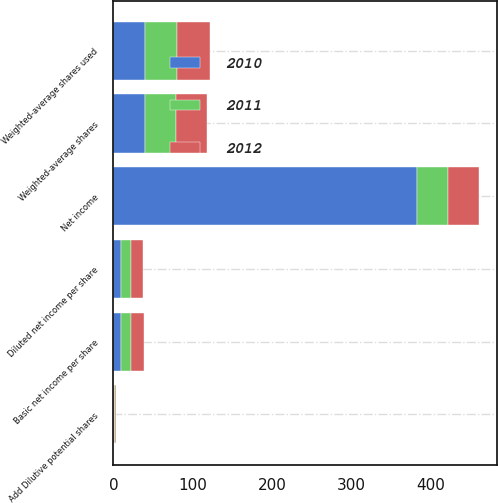Convert chart. <chart><loc_0><loc_0><loc_500><loc_500><stacked_bar_chart><ecel><fcel>Net income<fcel>Weighted-average shares<fcel>Basic net income per share<fcel>Add Dilutive potential shares<fcel>Weighted-average shares used<fcel>Diluted net income per share<nl><fcel>2012<fcel>39.2<fcel>39.8<fcel>16.5<fcel>1.3<fcel>41.1<fcel>15.98<nl><fcel>2011<fcel>39.2<fcel>39.2<fcel>12.63<fcel>1<fcel>40.2<fcel>12.32<nl><fcel>2010<fcel>381.8<fcel>39.2<fcel>9.74<fcel>1.1<fcel>40.3<fcel>9.47<nl></chart> 